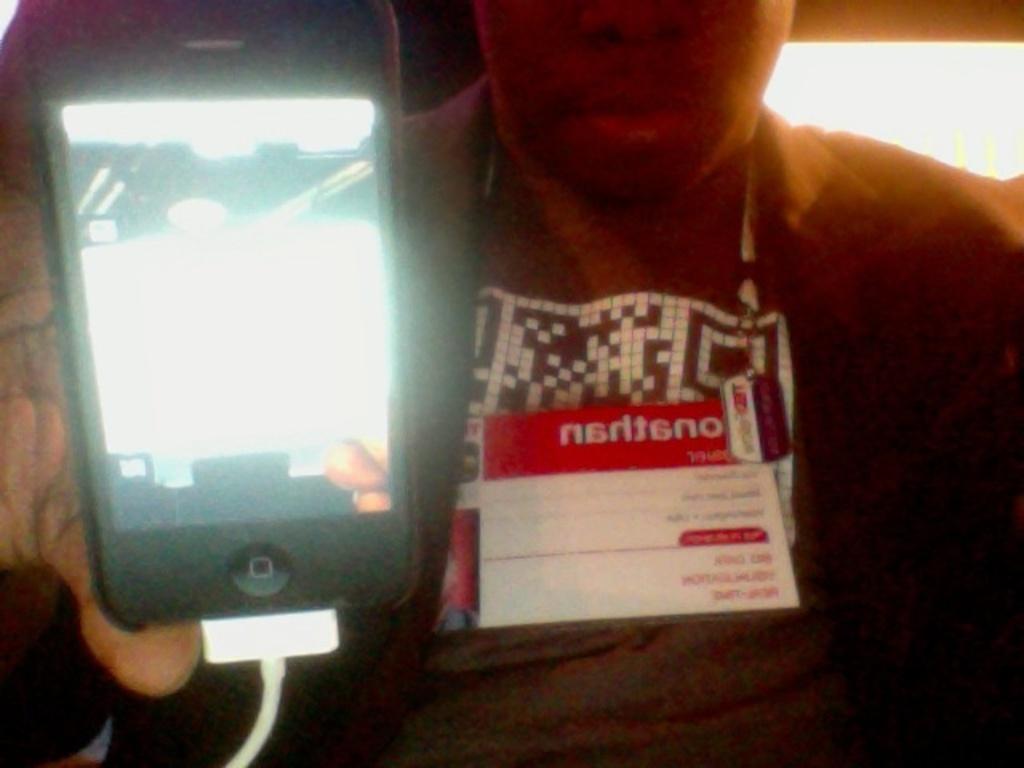Describe this image in one or two sentences. In this image there is a person who is showing the mobile which is connected to the charger. The man is having an id card. In the background there is a light. 